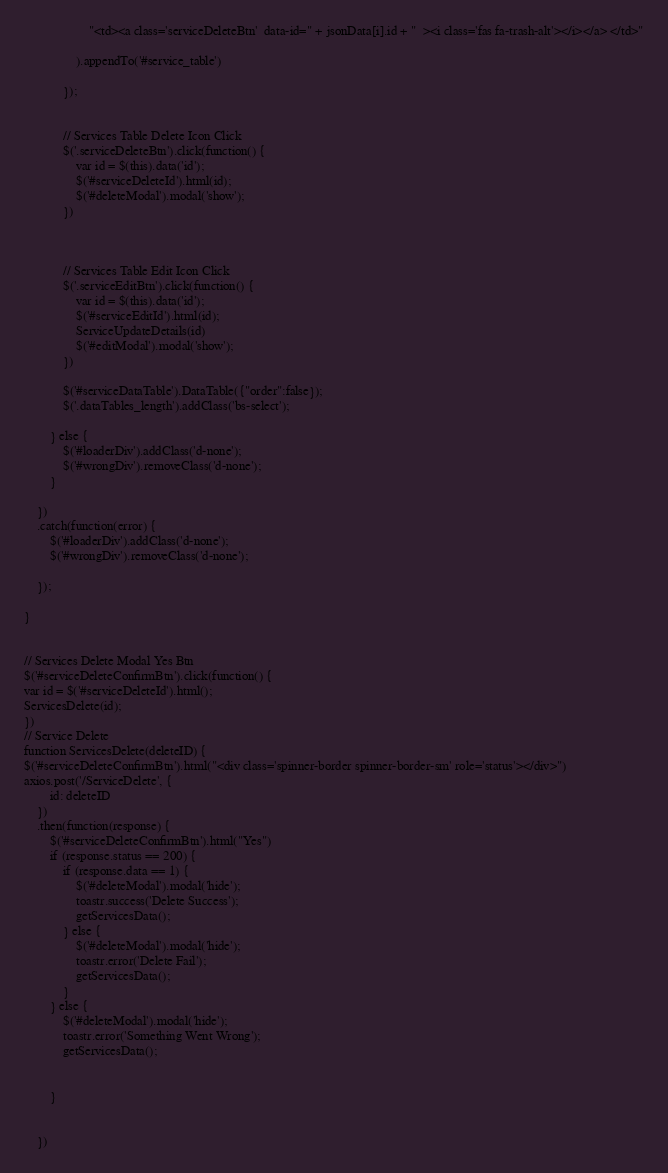<code> <loc_0><loc_0><loc_500><loc_500><_PHP_>                    "<td><a class='serviceDeleteBtn'  data-id=" + jsonData[i].id + "  ><i class='fas fa-trash-alt'></i></a> </td>"

                ).appendTo('#service_table')

            });


            // Services Table Delete Icon Click
            $('.serviceDeleteBtn').click(function() {
                var id = $(this).data('id');
                $('#serviceDeleteId').html(id);
                $('#deleteModal').modal('show');
            })



            // Services Table Edit Icon Click
            $('.serviceEditBtn').click(function() {
                var id = $(this).data('id');
                $('#serviceEditId').html(id);
                ServiceUpdateDetails(id)
                $('#editModal').modal('show');
            })

            $('#serviceDataTable').DataTable({"order":false});
            $('.dataTables_length').addClass('bs-select');
              
        } else {
            $('#loaderDiv').addClass('d-none');
            $('#wrongDiv').removeClass('d-none');
        }

    })
    .catch(function(error) {
        $('#loaderDiv').addClass('d-none');
        $('#wrongDiv').removeClass('d-none');

    });

}


// Services Delete Modal Yes Btn
$('#serviceDeleteConfirmBtn').click(function() {
var id = $('#serviceDeleteId').html();
ServicesDelete(id);
})
// Service Delete
function ServicesDelete(deleteID) {
$('#serviceDeleteConfirmBtn').html("<div class='spinner-border spinner-border-sm' role='status'></div>")
axios.post('/ServiceDelete', {
        id: deleteID
    })
    .then(function(response) {
        $('#serviceDeleteConfirmBtn').html("Yes")
        if (response.status == 200) {
            if (response.data == 1) {
                $('#deleteModal').modal('hide');
                toastr.success('Delete Success');
                getServicesData();
            } else {
                $('#deleteModal').modal('hide');
                toastr.error('Delete Fail');
                getServicesData();
            }
        } else {
            $('#deleteModal').modal('hide');
            toastr.error('Something Went Wrong');
            getServicesData();


        }


    })
</code> 